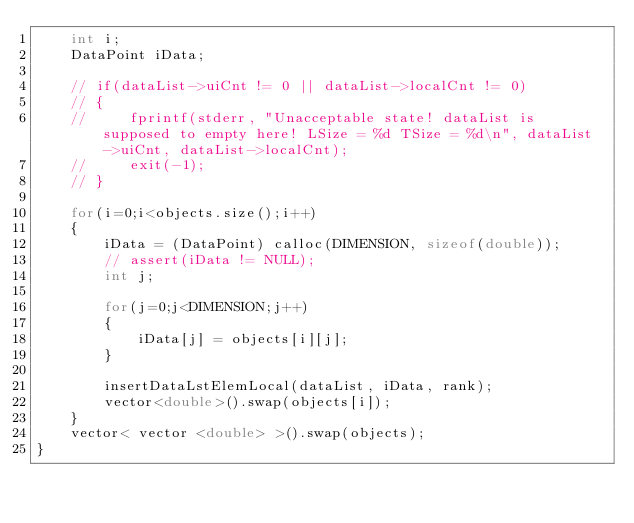<code> <loc_0><loc_0><loc_500><loc_500><_C++_>    int i;
    DataPoint iData;

    // if(dataList->uiCnt != 0 || dataList->localCnt != 0)
    // {
    //     fprintf(stderr, "Unacceptable state! dataList is supposed to empty here! LSize = %d TSize = %d\n", dataList->uiCnt, dataList->localCnt);
    //     exit(-1);
    // }

    for(i=0;i<objects.size();i++)
    {
        iData = (DataPoint) calloc(DIMENSION, sizeof(double));
        // assert(iData != NULL);
        int j;

        for(j=0;j<DIMENSION;j++)
        {
            iData[j] = objects[i][j];
        }

        insertDataLstElemLocal(dataList, iData, rank);
        vector<double>().swap(objects[i]);
    }
    vector< vector <double> >().swap(objects);
}

</code> 